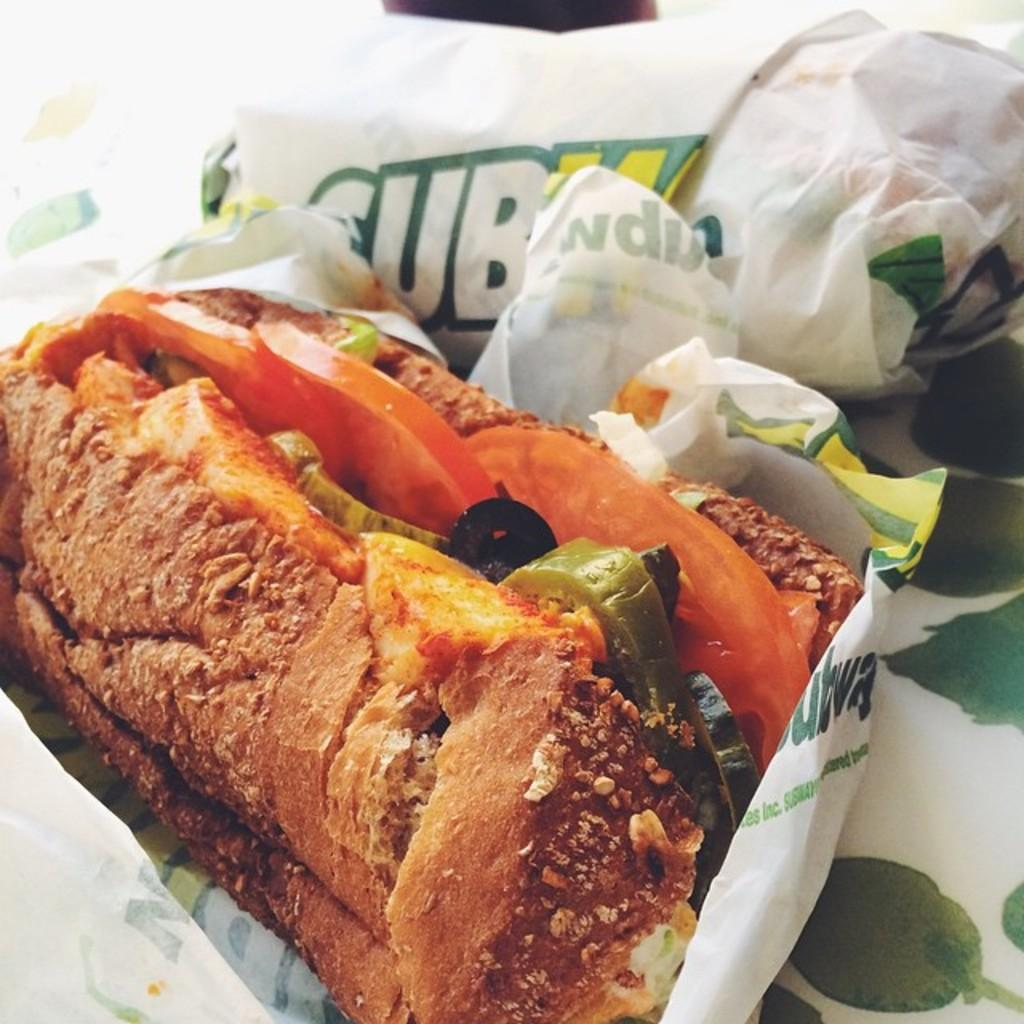What is on the table in the image? There are food packets on the table. Are all the food packets in the same state? No, some food packets are packed, while others are unpacked. Can you describe the condition of the packed food packets? The packed food packets are sealed and ready for use or storage. How can you differentiate between the packed and unpacked food packets? The unpacked food packets are open and have their contents exposed. What language is spoken by the bomb in the image? There is no bomb present in the image, so this question cannot be answered. 